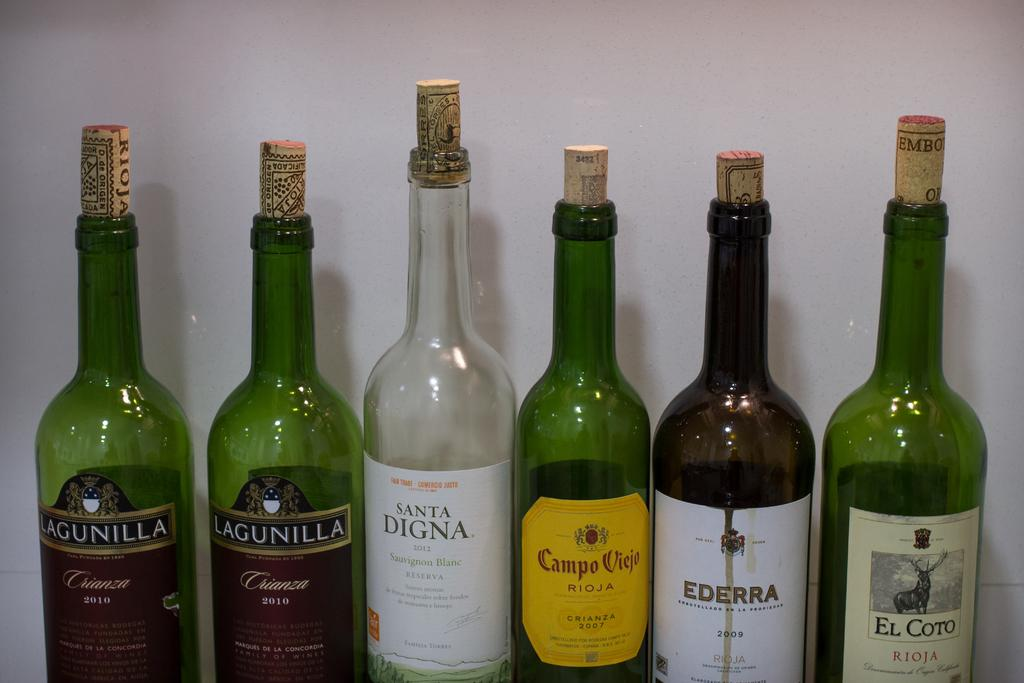<image>
Offer a succinct explanation of the picture presented. A row of wine bottles and two of them say Lagunilla. 